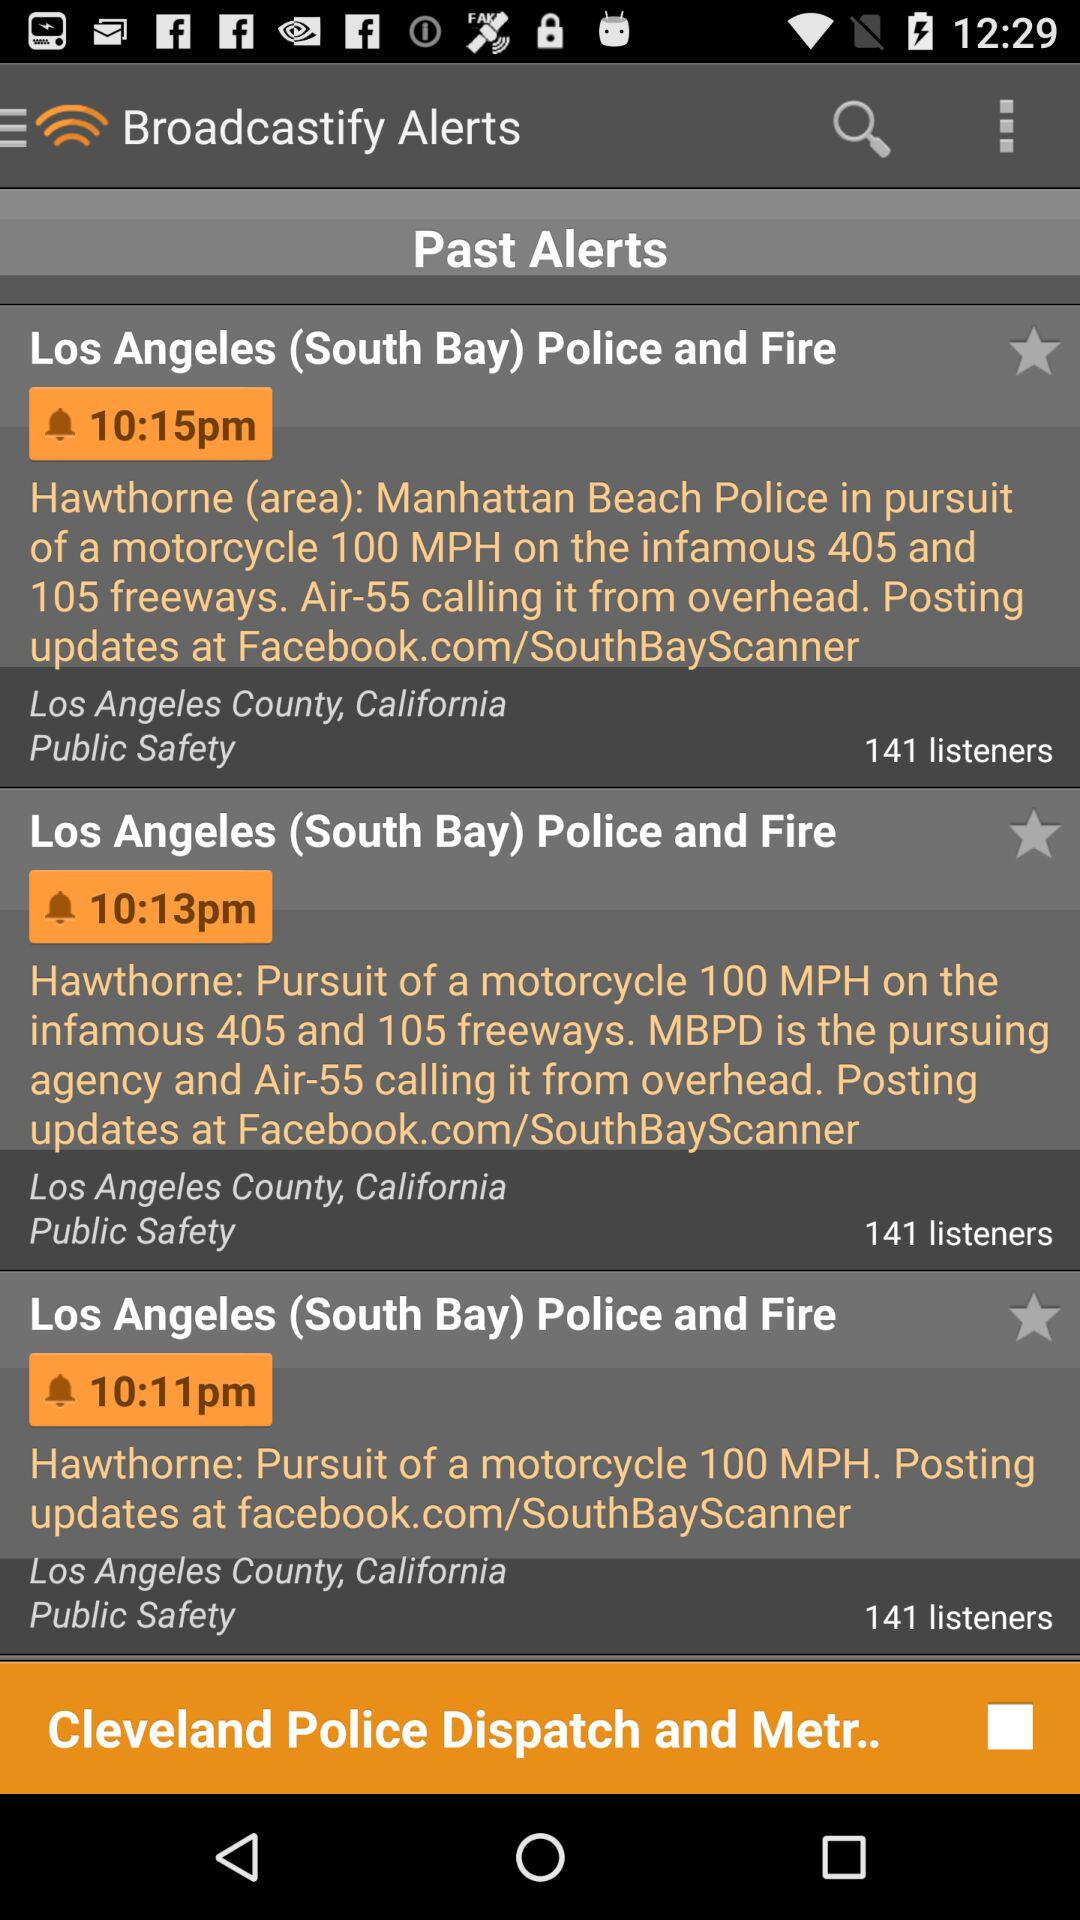What is the state shown on the screen? The state is California. 